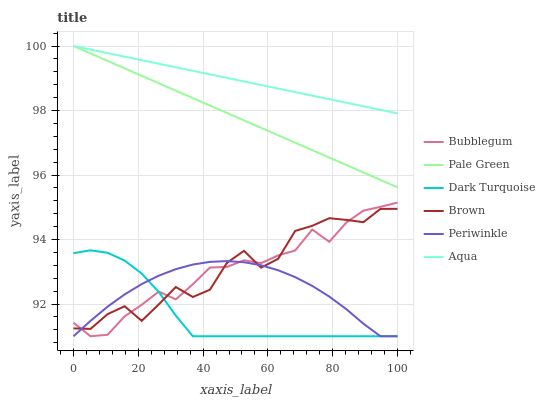Does Dark Turquoise have the minimum area under the curve?
Answer yes or no. Yes. Does Aqua have the maximum area under the curve?
Answer yes or no. Yes. Does Aqua have the minimum area under the curve?
Answer yes or no. No. Does Dark Turquoise have the maximum area under the curve?
Answer yes or no. No. Is Aqua the smoothest?
Answer yes or no. Yes. Is Brown the roughest?
Answer yes or no. Yes. Is Dark Turquoise the smoothest?
Answer yes or no. No. Is Dark Turquoise the roughest?
Answer yes or no. No. Does Dark Turquoise have the lowest value?
Answer yes or no. Yes. Does Aqua have the lowest value?
Answer yes or no. No. Does Pale Green have the highest value?
Answer yes or no. Yes. Does Dark Turquoise have the highest value?
Answer yes or no. No. Is Periwinkle less than Aqua?
Answer yes or no. Yes. Is Aqua greater than Dark Turquoise?
Answer yes or no. Yes. Does Aqua intersect Pale Green?
Answer yes or no. Yes. Is Aqua less than Pale Green?
Answer yes or no. No. Is Aqua greater than Pale Green?
Answer yes or no. No. Does Periwinkle intersect Aqua?
Answer yes or no. No. 